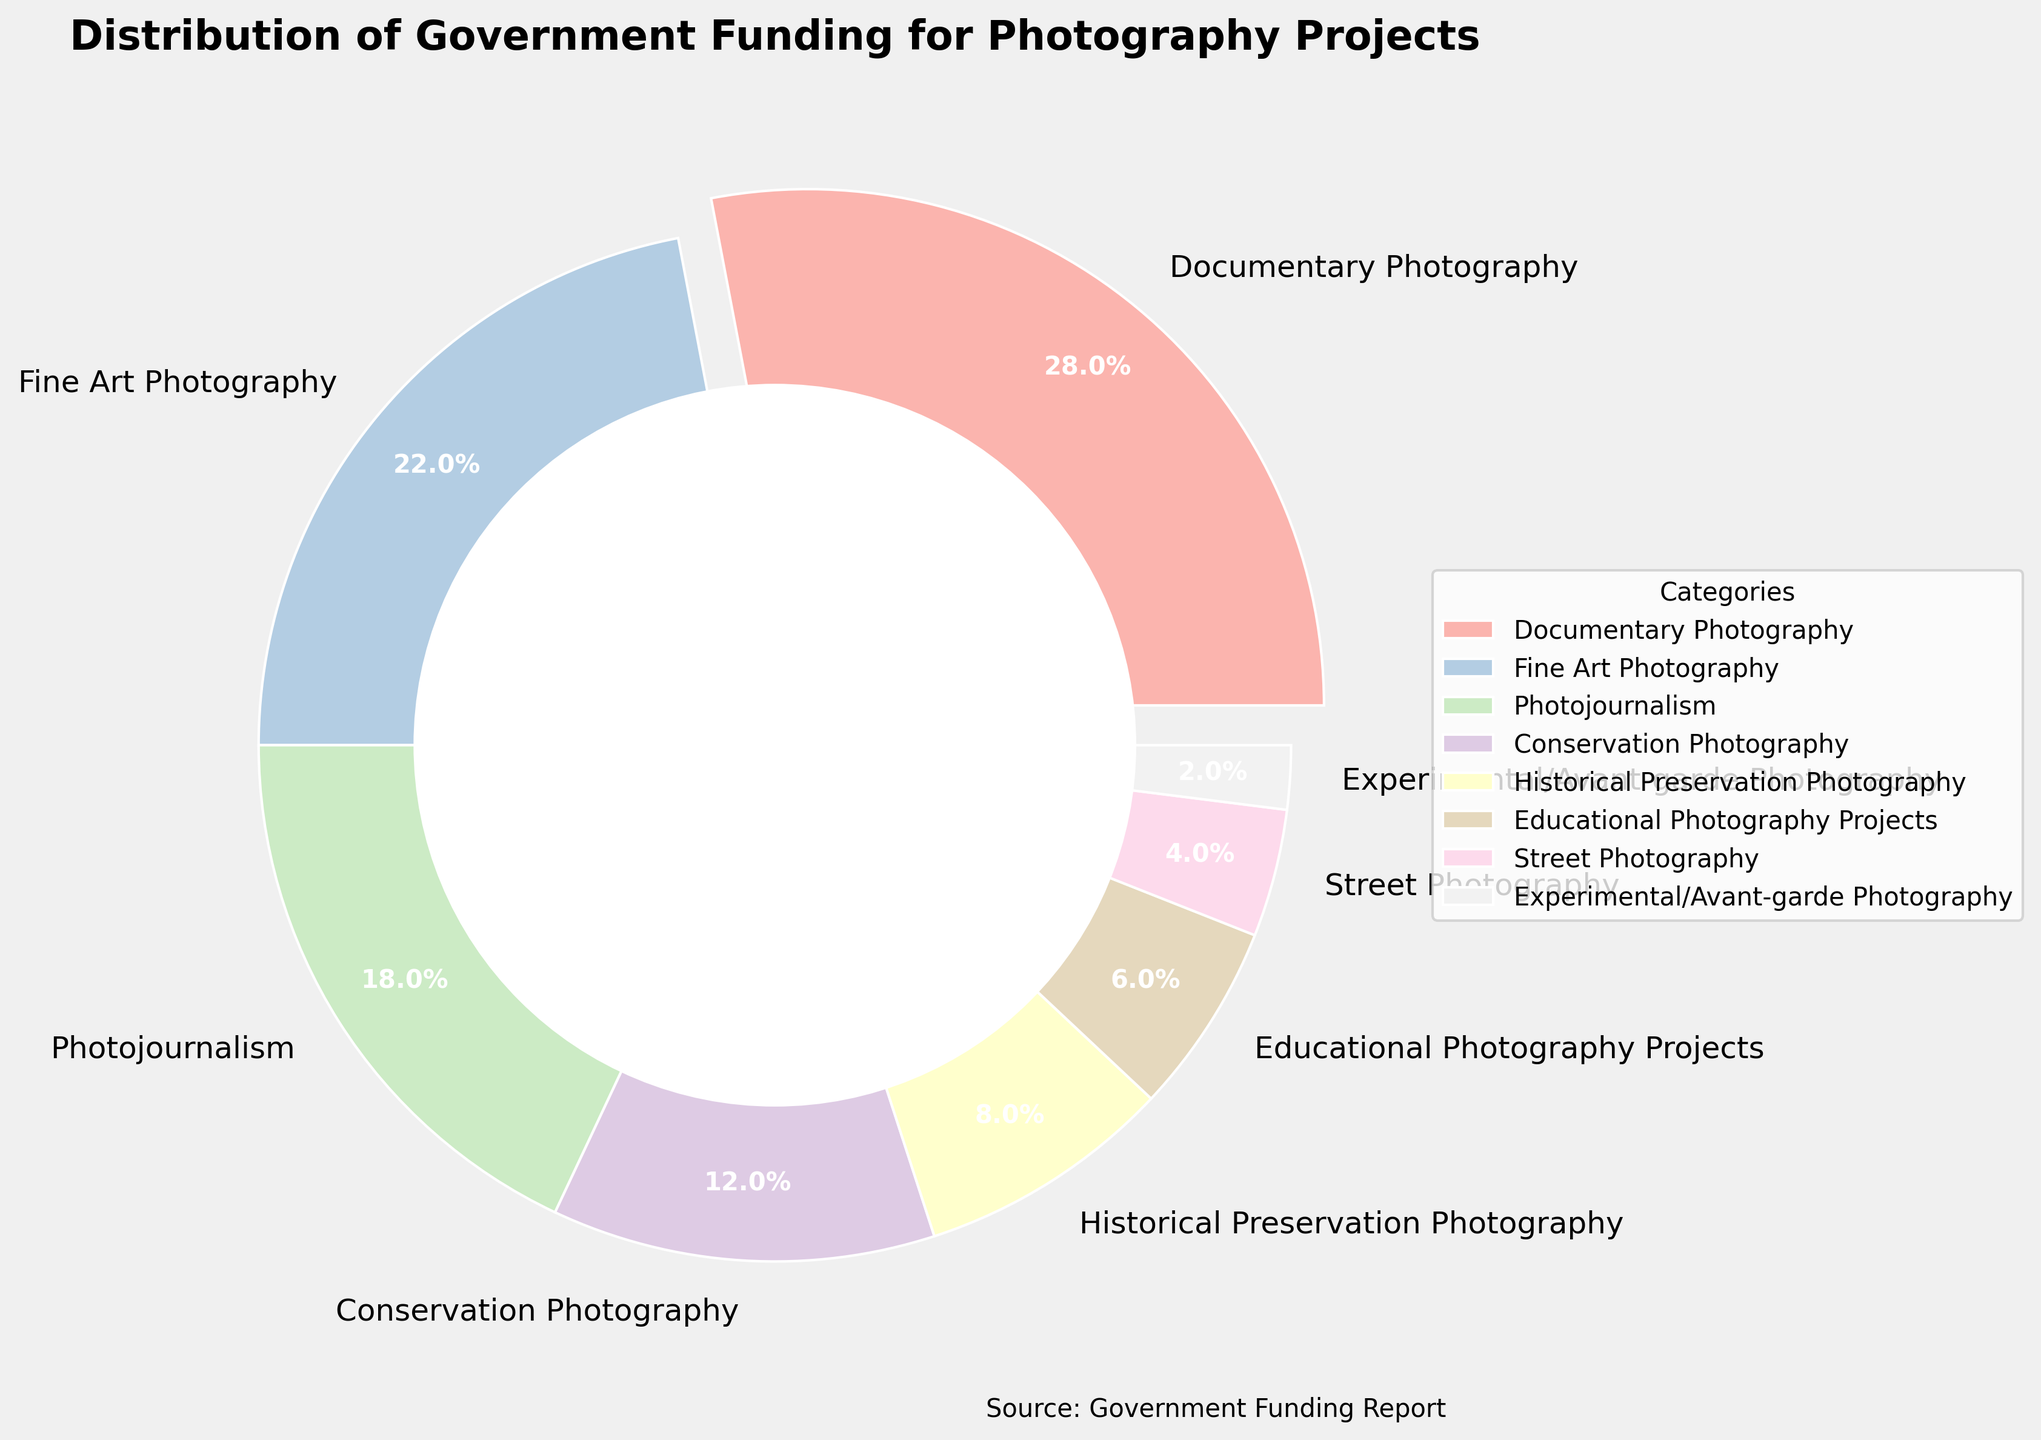What is the funding percentage for Fine Art Photography? The segment for Fine Art Photography is labeled, showing a funding percentage of 22%.
Answer: 22% Which category has the highest government funding percentage? The pie chart shows that "Documentary Photography" has the highest percentage with an exploded segment, indicating 28%.
Answer: Documentary Photography Is the funding for Street Photography greater or less than that for Photojournalism? The pie chart shows Street Photography at 4% and Photojournalism at 18%. Since 4% is less than 18%, the funding for Street Photography is less.
Answer: Less What is the total funding percentage for Conservation Photography and Educational Photography Projects combined? Conservation Photography is 12% and Educational Photography Projects is 6%. Combined, this is 12% + 6%.
Answer: 18% What is the difference in funding percentage between the highest and lowest funded categories? The highest is Documentary Photography at 28%. The lowest is Experimental/Avant-garde Photography at 2%. The difference is 28% - 2%.
Answer: 26% Which visual element has a wedge with an exploded segment, and why? The Documentary Photography segment has an exploded wedge, indicating it has the highest funding percentage at 28%.
Answer: Documentary Photography What funding category is placed at the top-right of the pie chart? Analyzing the visual placement, Historical Preservation Photography is located at the top-right section of the pie chart, labeled with 8%.
Answer: Historical Preservation Photography If you sum the funding percentages for categories related to journalism (Photojournalism and Documentary Photography), what is the result? Photojournalism is 18% and Documentary Photography is 28%. Combined, this is 18% + 28%.
Answer: 46% Which two categories, when their funding percentages are combined, approximate the funding percentage of Fine Art Photography? Historical Preservation Photography at 8% and Conservation Photography at 12% sum to a total of 20%, which is close to Fine Art Photography’s 22%.
Answer: Conservation Photography and Historical Preservation Photography Is the funding for Conservation Photography greater than the funding for Educational Photography Projects? The pie chart shows Conservation Photography at 12% and Educational Photography Projects at 6%. Since 12% is greater than 6%, yes, the funding for Conservation Photography is greater.
Answer: Yes 